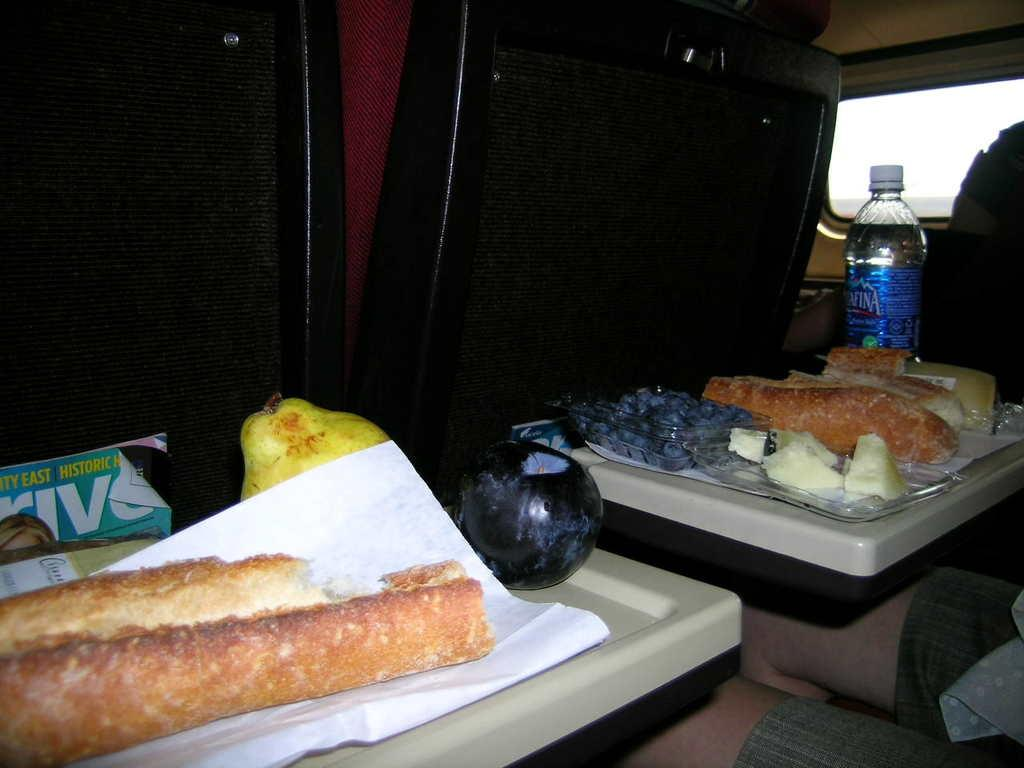What type of food items can be seen in the image? There are fruits in the image. What else can be seen on the table besides fruits? There is a bottle and a magazine on the table. Where are the items placed in the image? The items are placed on a table. What can be seen through the window in the image? The presence of a window suggests that there might be a view of the outdoors, but the specific view is not mentioned in the facts. Can you describe the seating arrangement in the image? There are seats in the image, but their specific arrangement is not mentioned in the facts. What type of writing can be seen on the wall in the image? There is no mention of any writing on the wall in the image, so it cannot be determined from the facts. 